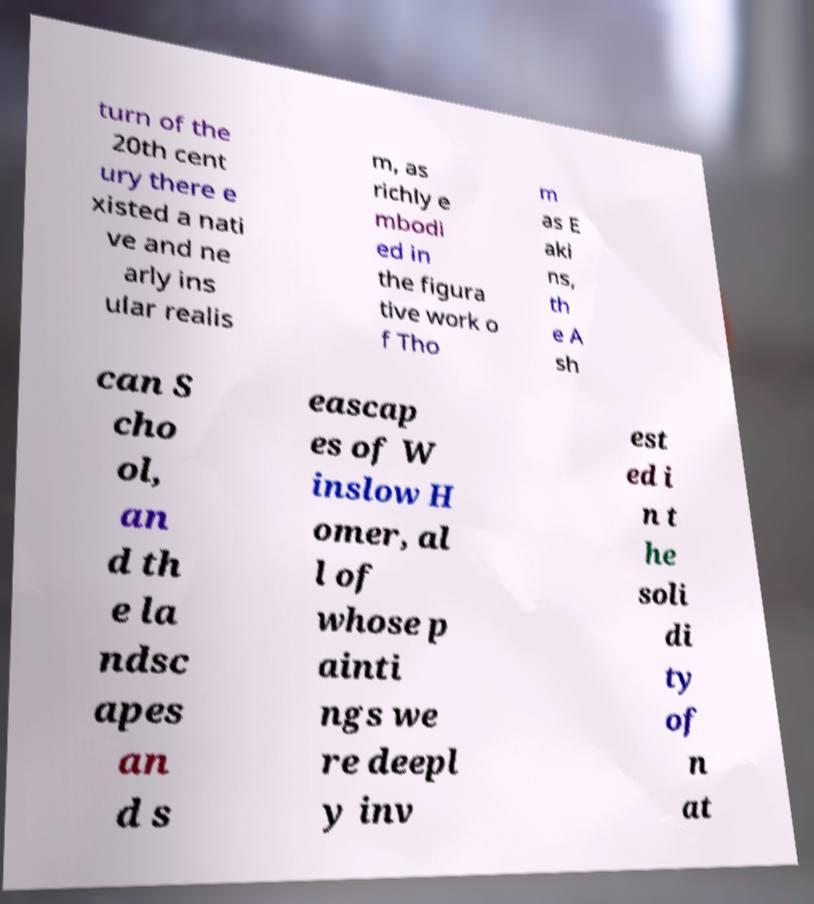What messages or text are displayed in this image? I need them in a readable, typed format. turn of the 20th cent ury there e xisted a nati ve and ne arly ins ular realis m, as richly e mbodi ed in the figura tive work o f Tho m as E aki ns, th e A sh can S cho ol, an d th e la ndsc apes an d s eascap es of W inslow H omer, al l of whose p ainti ngs we re deepl y inv est ed i n t he soli di ty of n at 